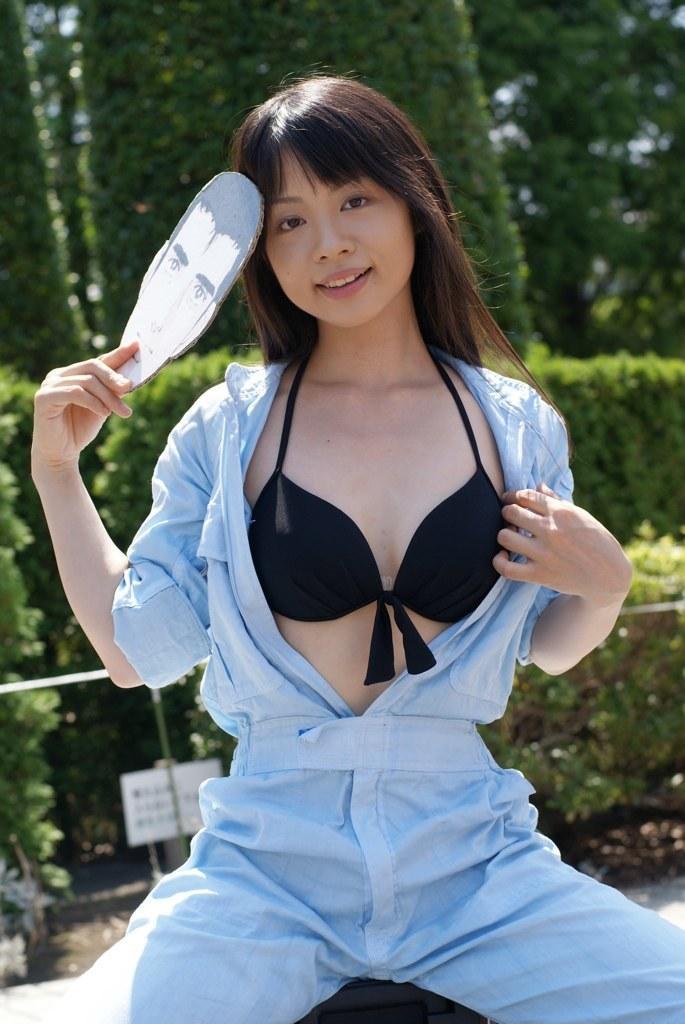Please provide a concise description of this image. In this picture I can see a woman sitting and holding an object. I can see a board, and in the background there are trees. 